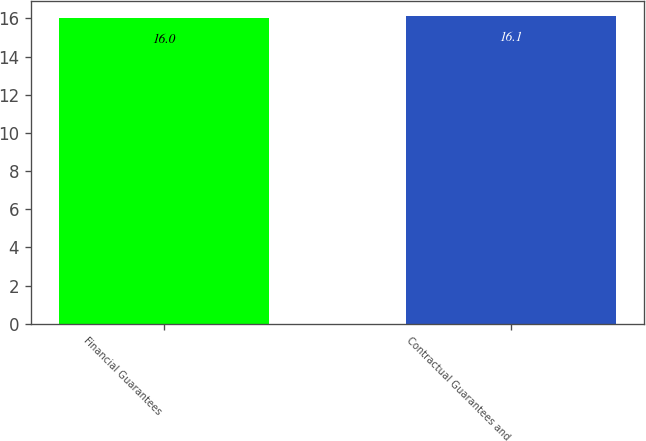Convert chart to OTSL. <chart><loc_0><loc_0><loc_500><loc_500><bar_chart><fcel>Financial Guarantees<fcel>Contractual Guarantees and<nl><fcel>16<fcel>16.1<nl></chart> 